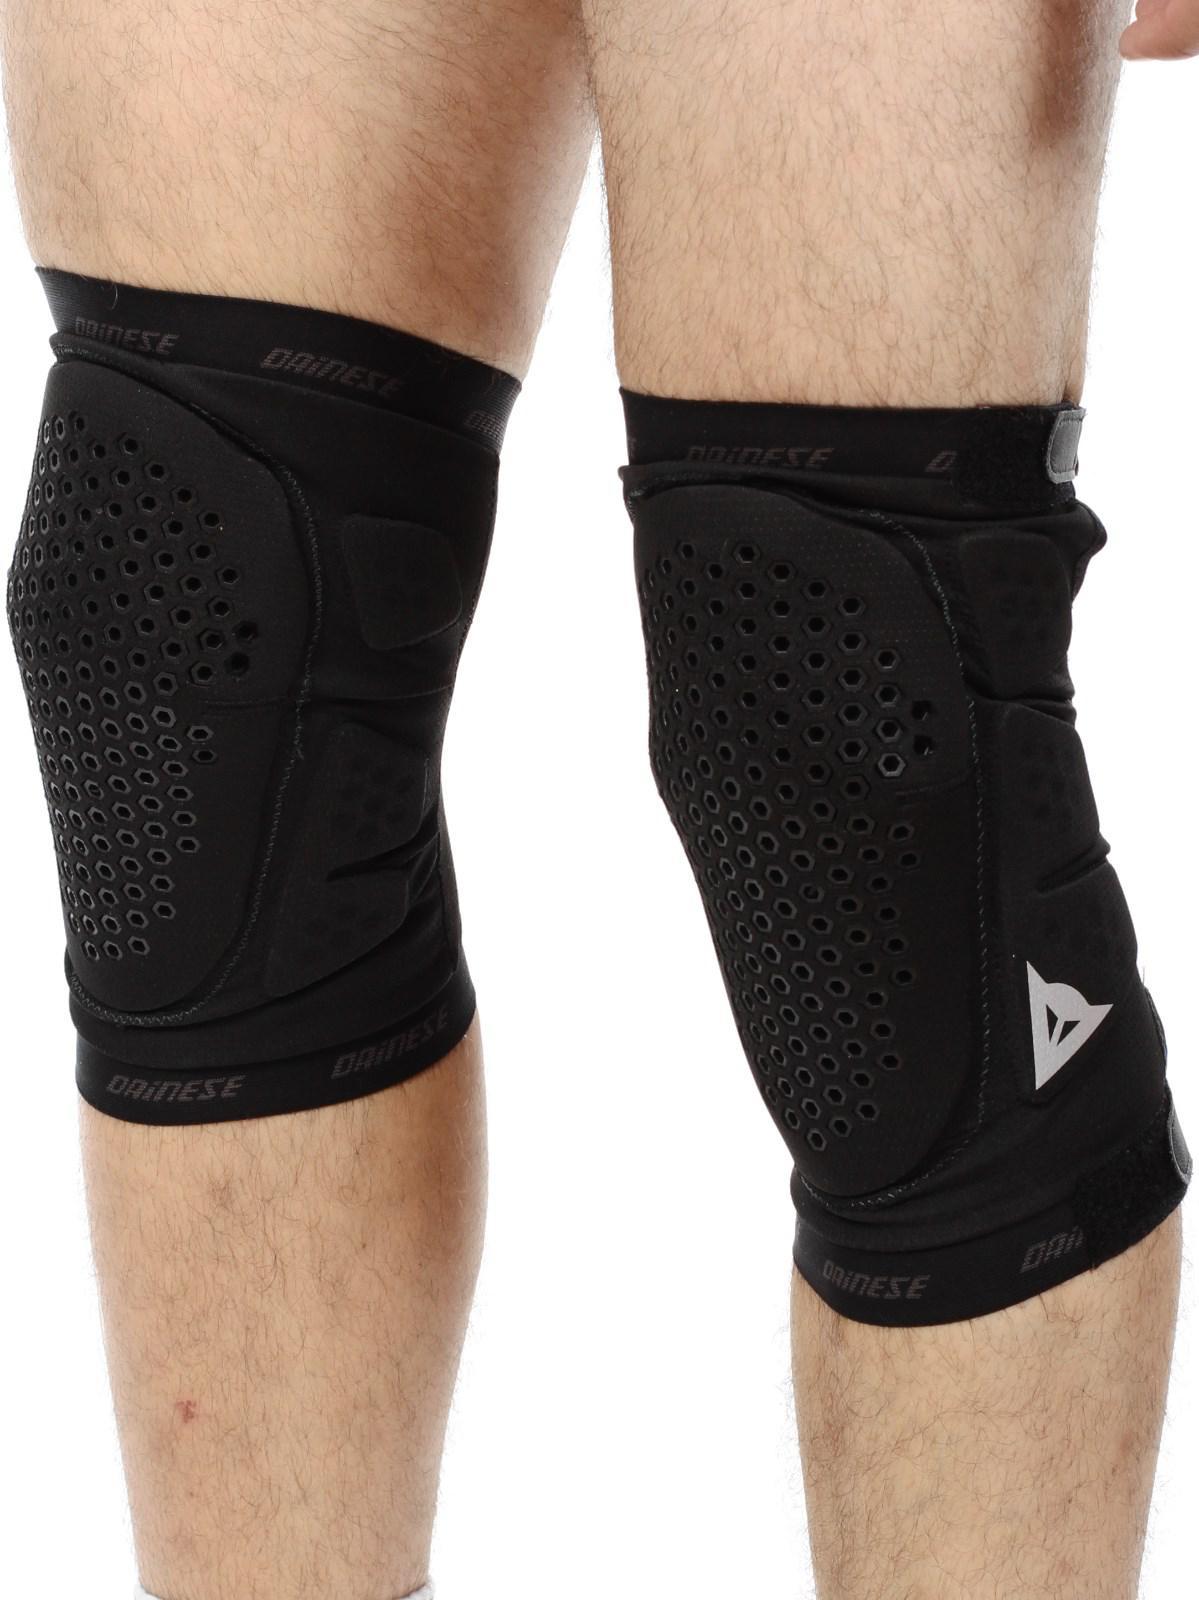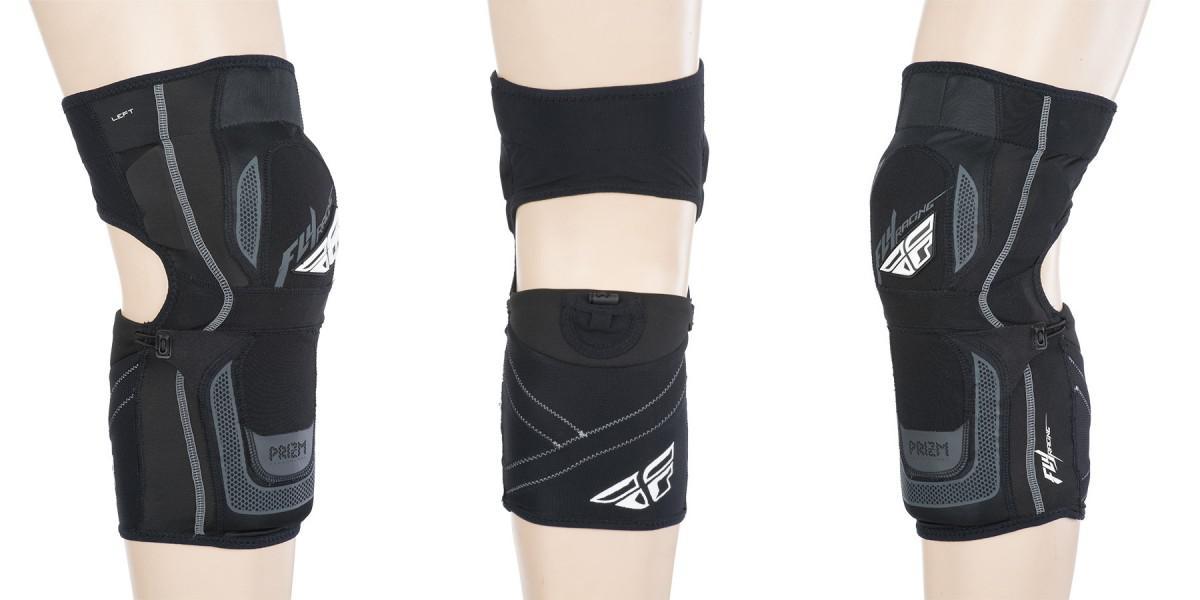The first image is the image on the left, the second image is the image on the right. For the images shown, is this caption "There are exactly four legs visible." true? Answer yes or no. No. The first image is the image on the left, the second image is the image on the right. Considering the images on both sides, is "There are two pairs of legs." valid? Answer yes or no. No. 